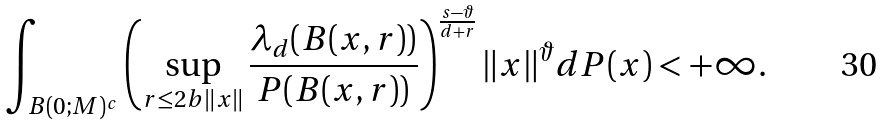<formula> <loc_0><loc_0><loc_500><loc_500>\int _ { B ( 0 ; M ) ^ { c } } \left ( \sup _ { r \leq 2 b \| x \| } \frac { \lambda _ { d } ( B ( x , r ) ) } { P ( B ( x , r ) ) } \right ) ^ { \frac { s - \vartheta } { d + r } } \| x \| ^ { \vartheta } d P ( x ) < + \infty .</formula> 